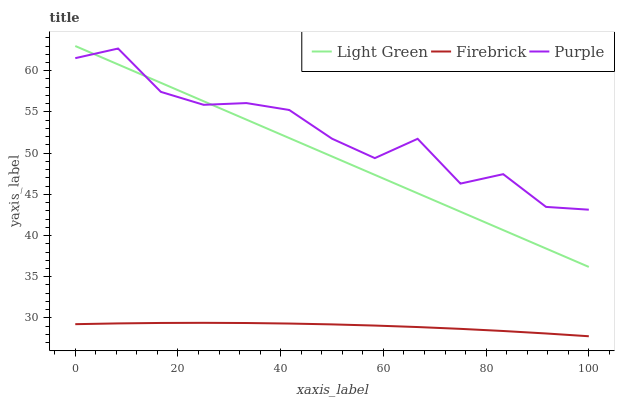Does Firebrick have the minimum area under the curve?
Answer yes or no. Yes. Does Purple have the maximum area under the curve?
Answer yes or no. Yes. Does Light Green have the minimum area under the curve?
Answer yes or no. No. Does Light Green have the maximum area under the curve?
Answer yes or no. No. Is Light Green the smoothest?
Answer yes or no. Yes. Is Purple the roughest?
Answer yes or no. Yes. Is Firebrick the smoothest?
Answer yes or no. No. Is Firebrick the roughest?
Answer yes or no. No. Does Firebrick have the lowest value?
Answer yes or no. Yes. Does Light Green have the lowest value?
Answer yes or no. No. Does Light Green have the highest value?
Answer yes or no. Yes. Does Firebrick have the highest value?
Answer yes or no. No. Is Firebrick less than Light Green?
Answer yes or no. Yes. Is Purple greater than Firebrick?
Answer yes or no. Yes. Does Light Green intersect Purple?
Answer yes or no. Yes. Is Light Green less than Purple?
Answer yes or no. No. Is Light Green greater than Purple?
Answer yes or no. No. Does Firebrick intersect Light Green?
Answer yes or no. No. 